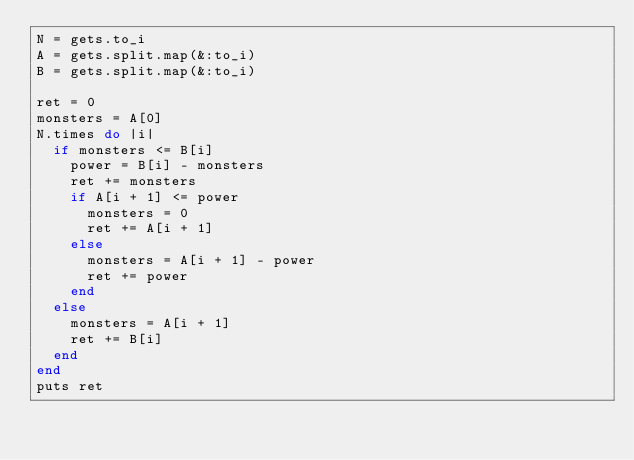Convert code to text. <code><loc_0><loc_0><loc_500><loc_500><_Ruby_>N = gets.to_i
A = gets.split.map(&:to_i)
B = gets.split.map(&:to_i)

ret = 0
monsters = A[0]
N.times do |i|
  if monsters <= B[i]
    power = B[i] - monsters
    ret += monsters
    if A[i + 1] <= power
      monsters = 0
      ret += A[i + 1]
    else
      monsters = A[i + 1] - power
      ret += power
    end
  else
    monsters = A[i + 1]
    ret += B[i]
  end
end
puts ret</code> 